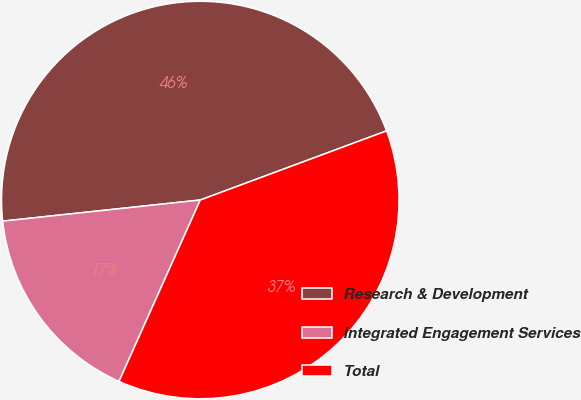Convert chart. <chart><loc_0><loc_0><loc_500><loc_500><pie_chart><fcel>Research & Development<fcel>Integrated Engagement Services<fcel>Total<nl><fcel>46.04%<fcel>16.6%<fcel>37.36%<nl></chart> 